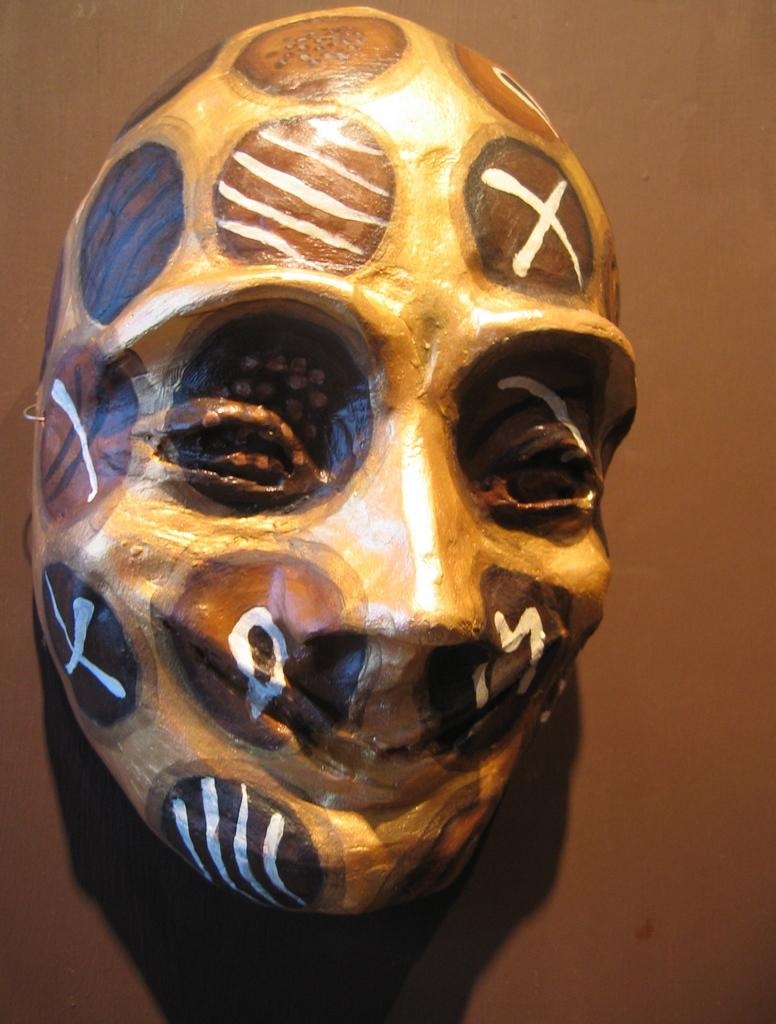What object can be seen in the image? There is a mask in the image. Where is the mask located? The mask is on a surface. What type of road is visible in the image? There is no road visible in the image; it only features a mask on a surface. 